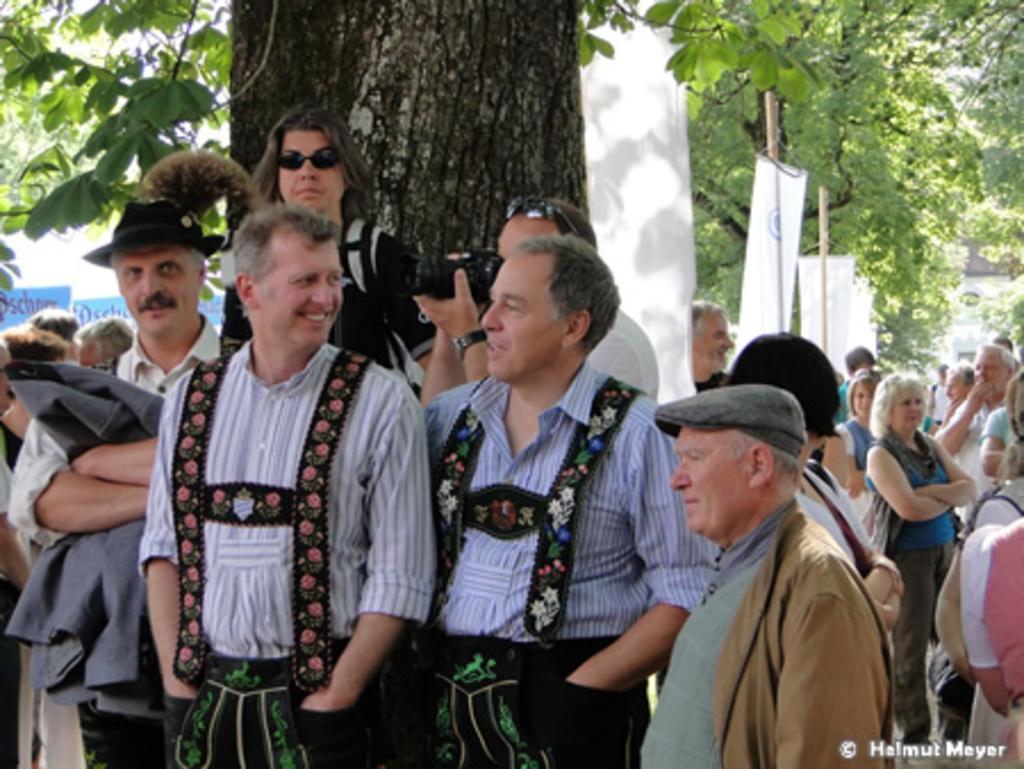How would you summarize this image in a sentence or two? In this image there are many people standing. In the foreground there are two men standing. They are smiling. Behind them there is a tree trunk. At the top there are leaves of a tree. Behind the trees there are banners to the poles. In the bottom right there is text on the image. 